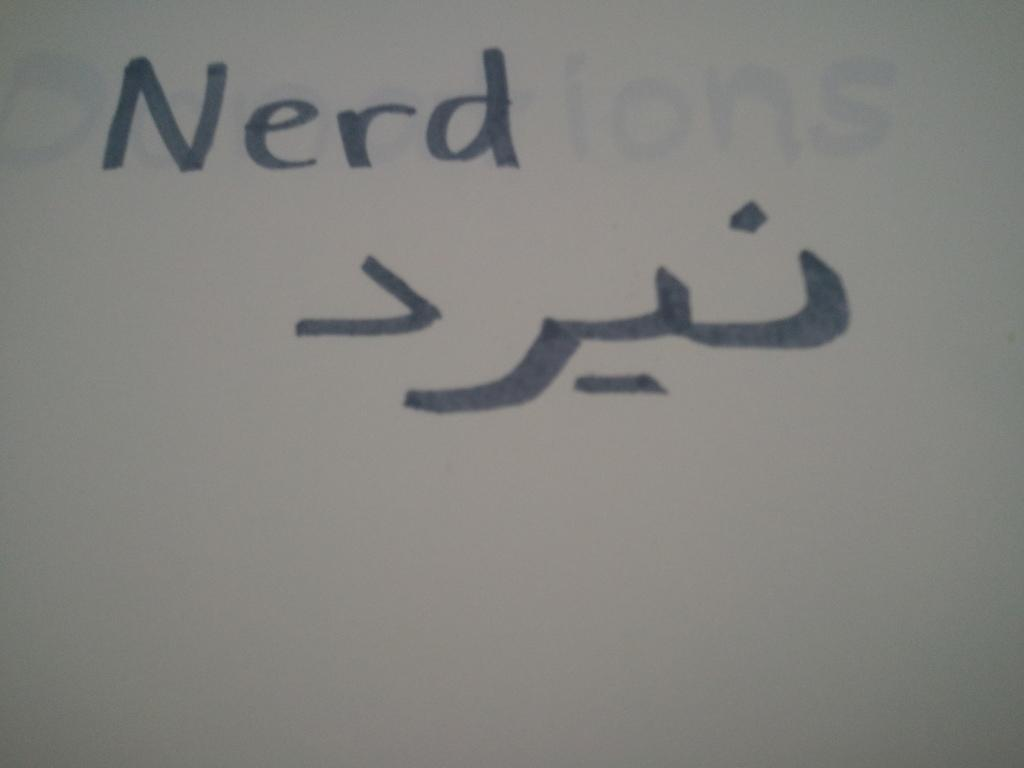Provide a one-sentence caption for the provided image. A white board with the word Nerd written in black with some symbols underneath the word. 